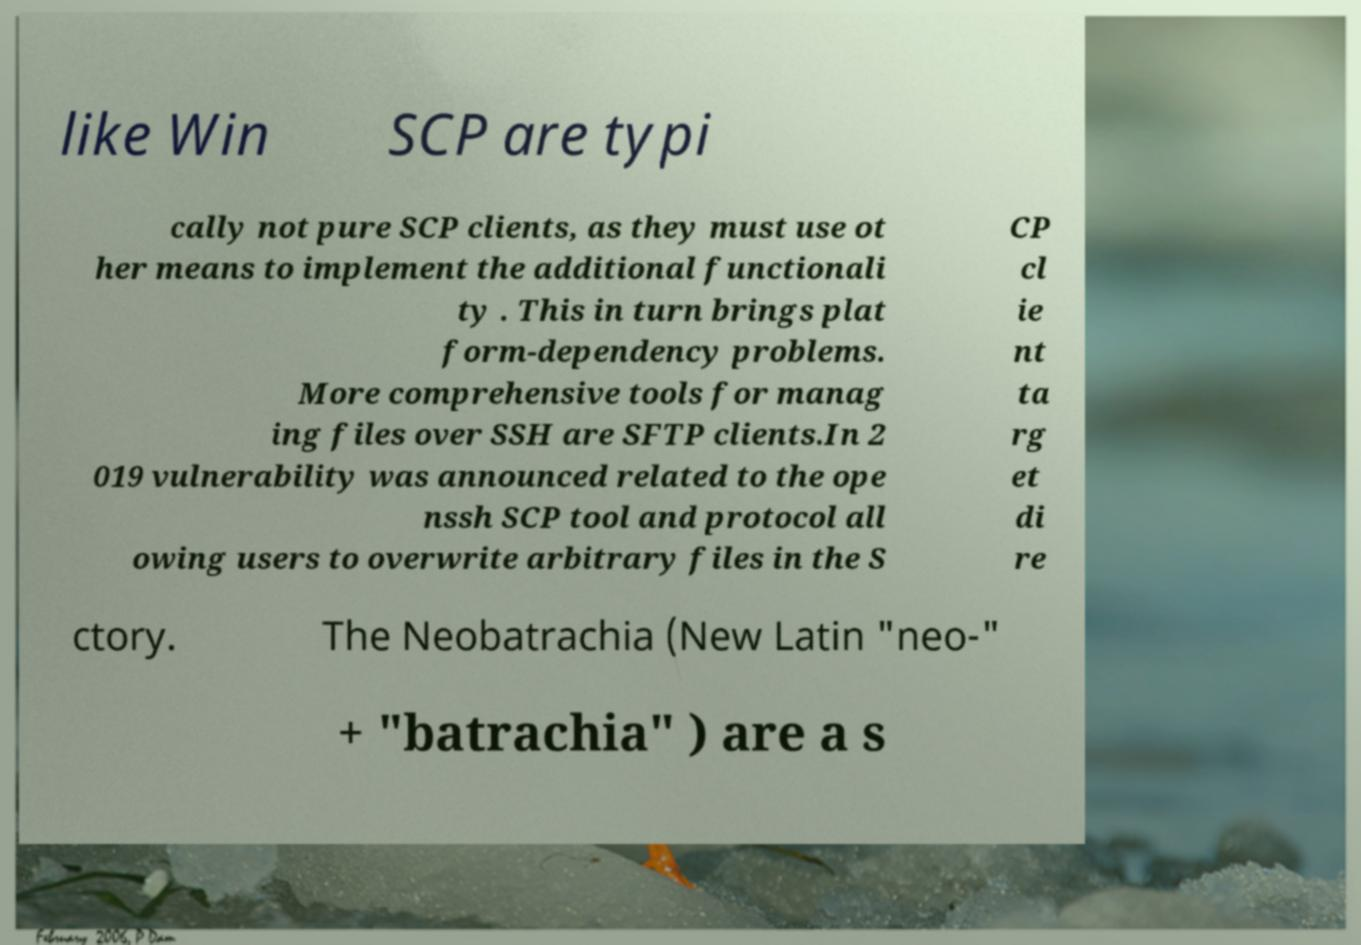Can you read and provide the text displayed in the image?This photo seems to have some interesting text. Can you extract and type it out for me? like Win SCP are typi cally not pure SCP clients, as they must use ot her means to implement the additional functionali ty . This in turn brings plat form-dependency problems. More comprehensive tools for manag ing files over SSH are SFTP clients.In 2 019 vulnerability was announced related to the ope nssh SCP tool and protocol all owing users to overwrite arbitrary files in the S CP cl ie nt ta rg et di re ctory. The Neobatrachia (New Latin "neo-" + "batrachia" ) are a s 